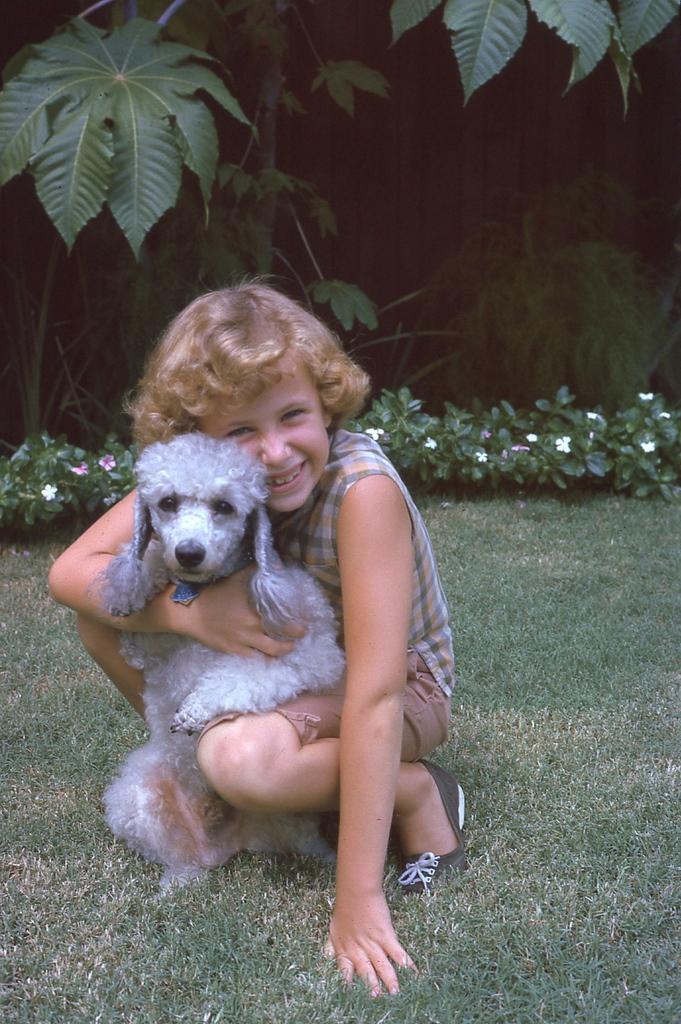Please provide a concise description of this image. On the background we can see plants. these are flower plants. This is a grass area. Here we can see one girl holding a dog with her hand. 